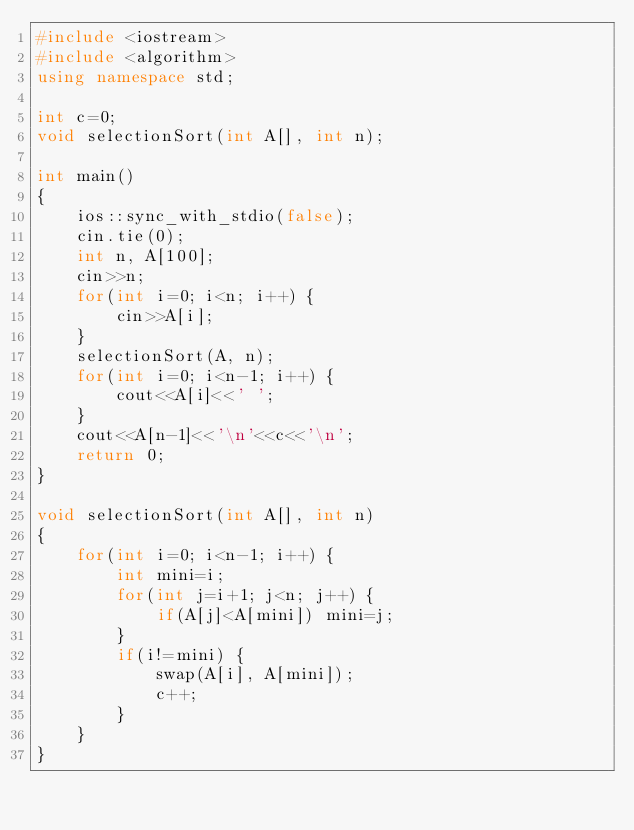<code> <loc_0><loc_0><loc_500><loc_500><_C++_>#include <iostream>
#include <algorithm>
using namespace std;

int c=0;
void selectionSort(int A[], int n);

int main()
{
    ios::sync_with_stdio(false);
    cin.tie(0);
    int n, A[100];
    cin>>n;
    for(int i=0; i<n; i++) {
        cin>>A[i];
    }
    selectionSort(A, n);
    for(int i=0; i<n-1; i++) {
        cout<<A[i]<<' ';
    }
    cout<<A[n-1]<<'\n'<<c<<'\n';
    return 0;
}

void selectionSort(int A[], int n)
{
    for(int i=0; i<n-1; i++) {
        int mini=i;
        for(int j=i+1; j<n; j++) {
            if(A[j]<A[mini]) mini=j;
        }
        if(i!=mini) {
            swap(A[i], A[mini]);
            c++;
        }
    }
}</code> 